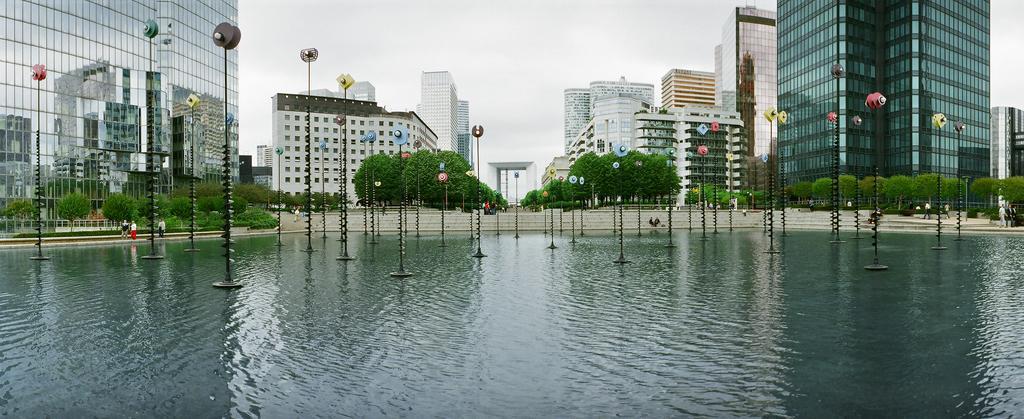Describe this image in one or two sentences. There are poles present on the surface of water as we can at the bottom of this image. We can see trees and buildings in the middle background and the sky is at the top of this image. 